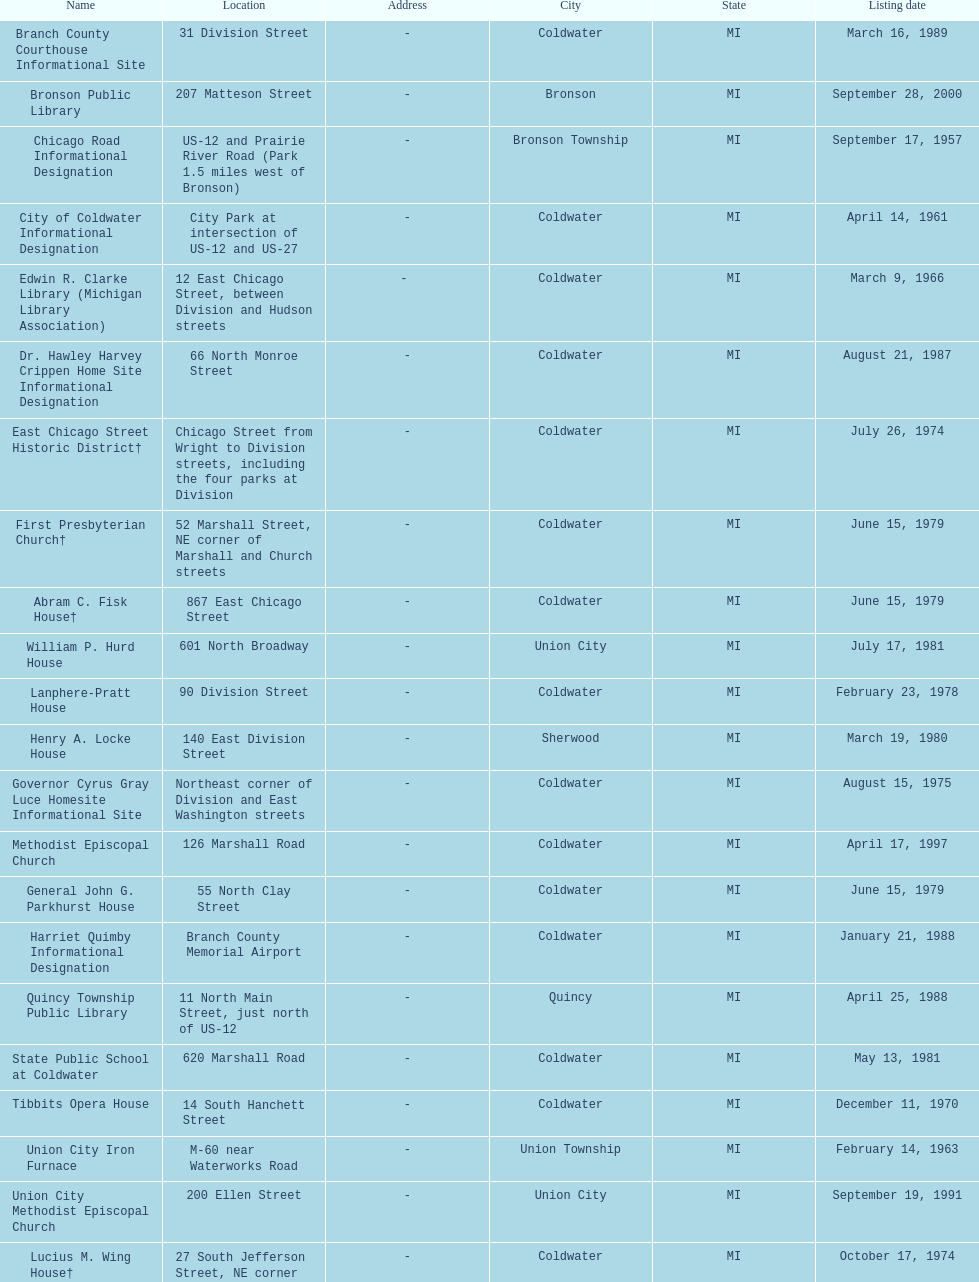Which site was listed earlier, the state public school or the edwin r. clarke library? Edwin R. Clarke Library. Help me parse the entirety of this table. {'header': ['Name', 'Location', 'Address', 'City', 'State', 'Listing date'], 'rows': [['Branch County Courthouse Informational Site', '31 Division Street', '-', 'Coldwater', 'MI', 'March 16, 1989'], ['Bronson Public Library', '207 Matteson Street', '-', 'Bronson', 'MI', 'September 28, 2000'], ['Chicago Road Informational Designation', 'US-12 and Prairie River Road (Park 1.5 miles west of Bronson)', '-', 'Bronson Township', 'MI', 'September 17, 1957'], ['City of Coldwater Informational Designation', 'City Park at intersection of US-12 and US-27', '-', 'Coldwater', 'MI', 'April 14, 1961'], ['Edwin R. Clarke Library (Michigan Library Association)', '12 East Chicago Street, between Division and Hudson streets', '- ', 'Coldwater', 'MI', 'March 9, 1966'], ['Dr. Hawley Harvey Crippen Home Site Informational Designation', '66 North Monroe Street', '-', 'Coldwater', 'MI', 'August 21, 1987'], ['East Chicago Street Historic District†', 'Chicago Street from Wright to Division streets, including the four parks at Division', '-', 'Coldwater', 'MI', 'July 26, 1974'], ['First Presbyterian Church†', '52 Marshall Street, NE corner of Marshall and Church streets', '-', 'Coldwater', 'MI', 'June 15, 1979'], ['Abram C. Fisk House†', '867 East Chicago Street', '-', 'Coldwater', 'MI', 'June 15, 1979'], ['William P. Hurd House', '601 North Broadway', '-', 'Union City', 'MI', 'July 17, 1981'], ['Lanphere-Pratt House', '90 Division Street', '-', 'Coldwater', 'MI', 'February 23, 1978'], ['Henry A. Locke House', '140 East Division Street', '-', 'Sherwood', 'MI', 'March 19, 1980'], ['Governor Cyrus Gray Luce Homesite Informational Site', 'Northeast corner of Division and East Washington streets', '-', 'Coldwater', 'MI', 'August 15, 1975'], ['Methodist Episcopal Church', '126 Marshall Road', '-', 'Coldwater', 'MI', 'April 17, 1997'], ['General John G. Parkhurst House', '55 North Clay Street', '-', 'Coldwater', 'MI', 'June 15, 1979'], ['Harriet Quimby Informational Designation', 'Branch County Memorial Airport', '-', 'Coldwater', 'MI', 'January 21, 1988'], ['Quincy Township Public Library', '11 North Main Street, just north of US-12', '-', 'Quincy', 'MI', 'April 25, 1988'], ['State Public School at Coldwater', '620 Marshall Road', '-', 'Coldwater', 'MI', 'May 13, 1981'], ['Tibbits Opera House', '14 South Hanchett Street', '-', 'Coldwater', 'MI', 'December 11, 1970'], ['Union City Iron Furnace', 'M-60 near Waterworks Road', '-', 'Union Township', 'MI', 'February 14, 1963'], ['Union City Methodist Episcopal Church', '200 Ellen Street', '-', 'Union City', 'MI', 'September 19, 1991'], ['Lucius M. Wing House†', '27 South Jefferson Street, NE corner of S. Jefferson and East Pearl Street', '-', 'Coldwater', 'MI', 'October 17, 1974'], ['John D. Zimmerman House', '119 East High Street', '-', 'Union City', 'MI', 'September 21, 1983']]} 